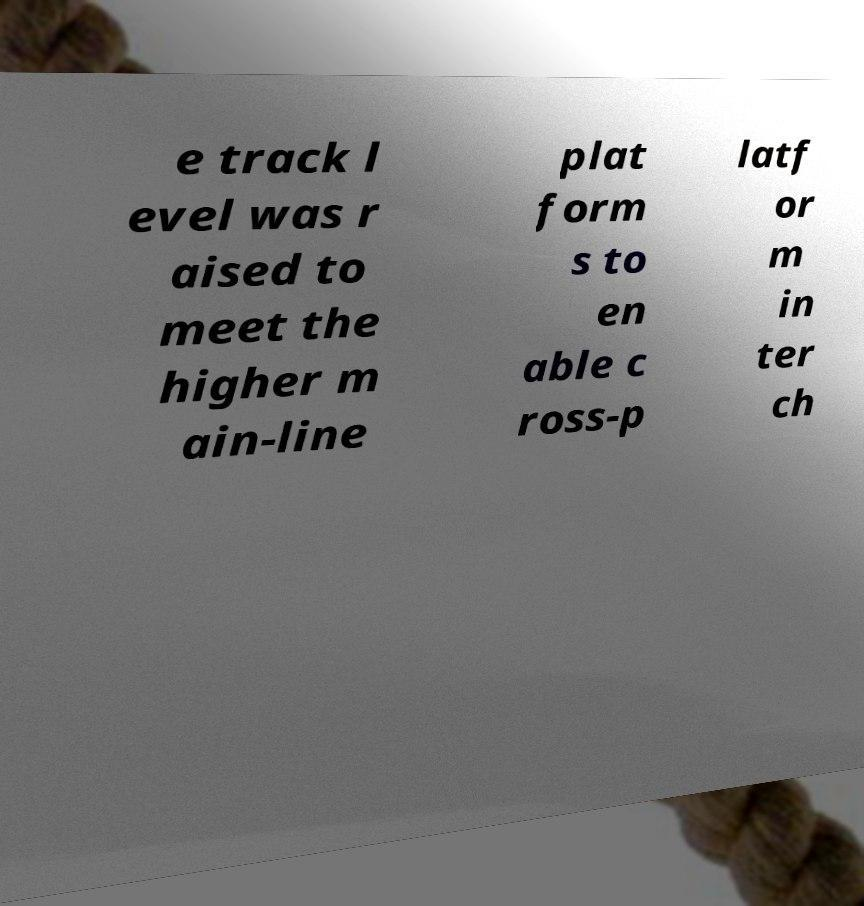Could you extract and type out the text from this image? e track l evel was r aised to meet the higher m ain-line plat form s to en able c ross-p latf or m in ter ch 